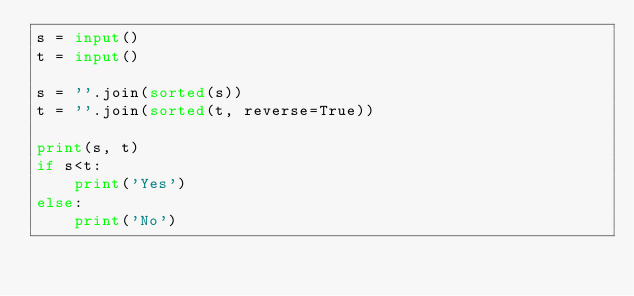Convert code to text. <code><loc_0><loc_0><loc_500><loc_500><_Python_>s = input()
t = input()

s = ''.join(sorted(s))
t = ''.join(sorted(t, reverse=True))

print(s, t)
if s<t:
    print('Yes')
else:
    print('No')</code> 